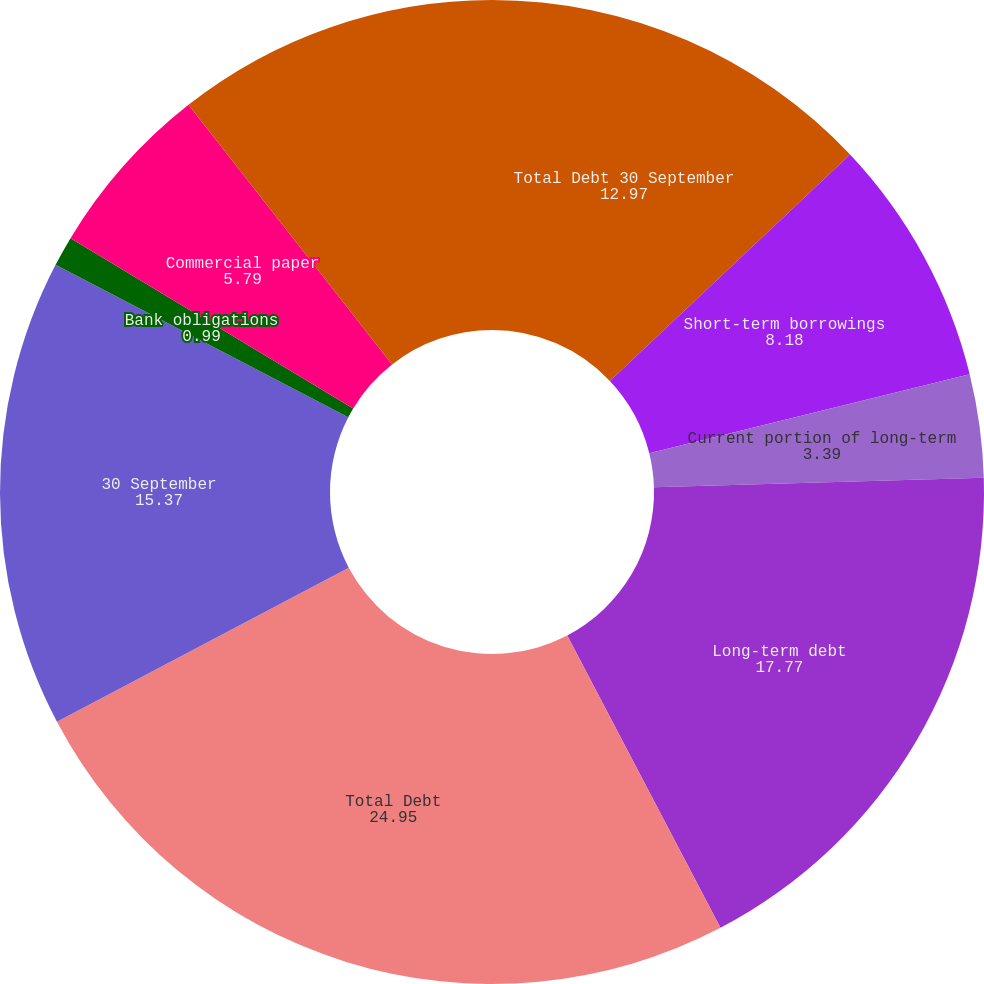Convert chart to OTSL. <chart><loc_0><loc_0><loc_500><loc_500><pie_chart><fcel>Total Debt 30 September<fcel>Short-term borrowings<fcel>Current portion of long-term<fcel>Long-term debt<fcel>Total Debt<fcel>30 September<fcel>Bank obligations<fcel>Commercial paper<fcel>Total Short-term Borrowings<nl><fcel>12.97%<fcel>8.18%<fcel>3.39%<fcel>17.77%<fcel>24.95%<fcel>15.37%<fcel>0.99%<fcel>5.79%<fcel>10.58%<nl></chart> 